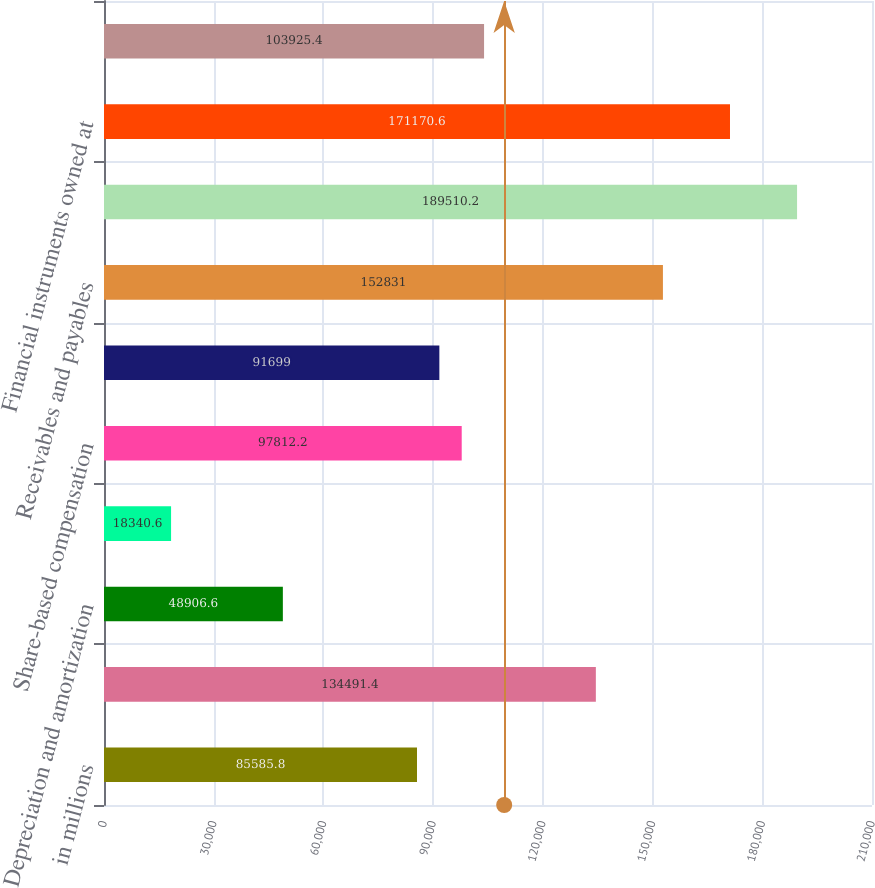<chart> <loc_0><loc_0><loc_500><loc_500><bar_chart><fcel>in millions<fcel>Net earnings<fcel>Depreciation and amortization<fcel>Deferred income taxes<fcel>Share-based compensation<fcel>Cash and securities segregated<fcel>Receivables and payables<fcel>Collateralized transactions<fcel>Financial instruments owned at<fcel>Financial instruments sold but<nl><fcel>85585.8<fcel>134491<fcel>48906.6<fcel>18340.6<fcel>97812.2<fcel>91699<fcel>152831<fcel>189510<fcel>171171<fcel>103925<nl></chart> 